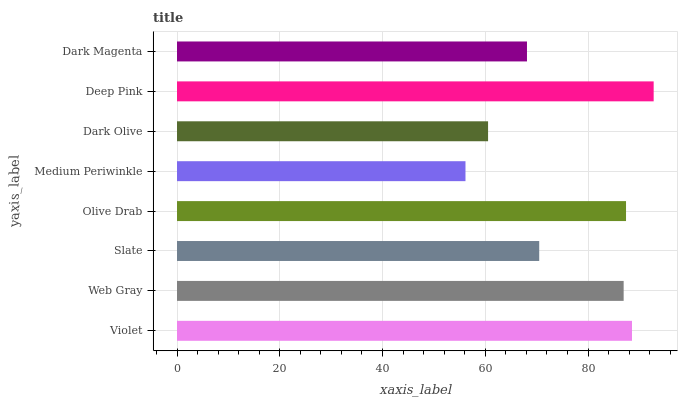Is Medium Periwinkle the minimum?
Answer yes or no. Yes. Is Deep Pink the maximum?
Answer yes or no. Yes. Is Web Gray the minimum?
Answer yes or no. No. Is Web Gray the maximum?
Answer yes or no. No. Is Violet greater than Web Gray?
Answer yes or no. Yes. Is Web Gray less than Violet?
Answer yes or no. Yes. Is Web Gray greater than Violet?
Answer yes or no. No. Is Violet less than Web Gray?
Answer yes or no. No. Is Web Gray the high median?
Answer yes or no. Yes. Is Slate the low median?
Answer yes or no. Yes. Is Violet the high median?
Answer yes or no. No. Is Web Gray the low median?
Answer yes or no. No. 